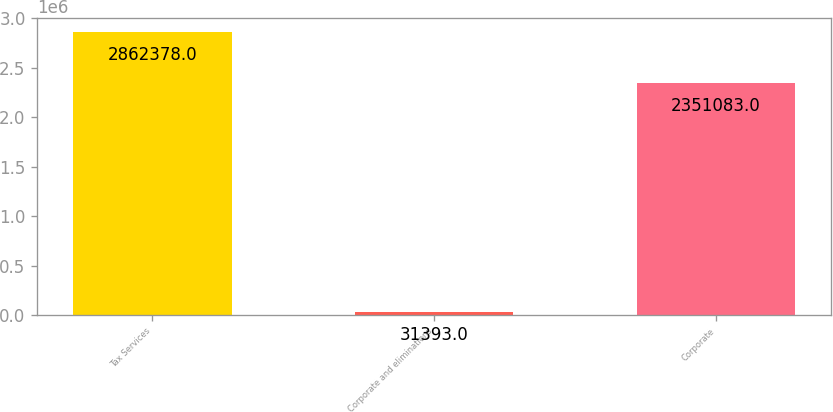Convert chart to OTSL. <chart><loc_0><loc_0><loc_500><loc_500><bar_chart><fcel>Tax Services<fcel>Corporate and eliminations<fcel>Corporate<nl><fcel>2.86238e+06<fcel>31393<fcel>2.35108e+06<nl></chart> 